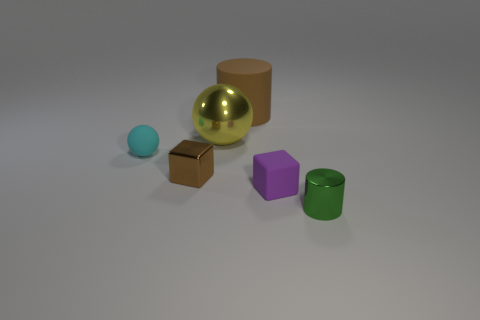Are there any objects that look the same in shape or color? No, each object has a unique shape and color. However, two objects share a similar color: the cylinder and the small shiny cube are both green. 